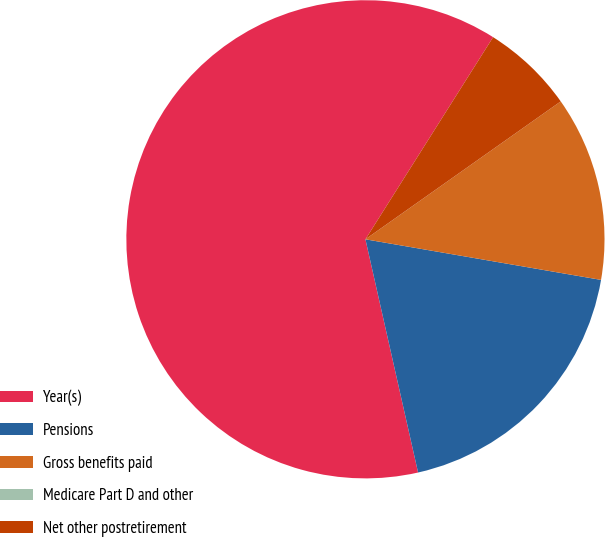<chart> <loc_0><loc_0><loc_500><loc_500><pie_chart><fcel>Year(s)<fcel>Pensions<fcel>Gross benefits paid<fcel>Medicare Part D and other<fcel>Net other postretirement<nl><fcel>62.5%<fcel>18.75%<fcel>12.5%<fcel>0.0%<fcel>6.25%<nl></chart> 